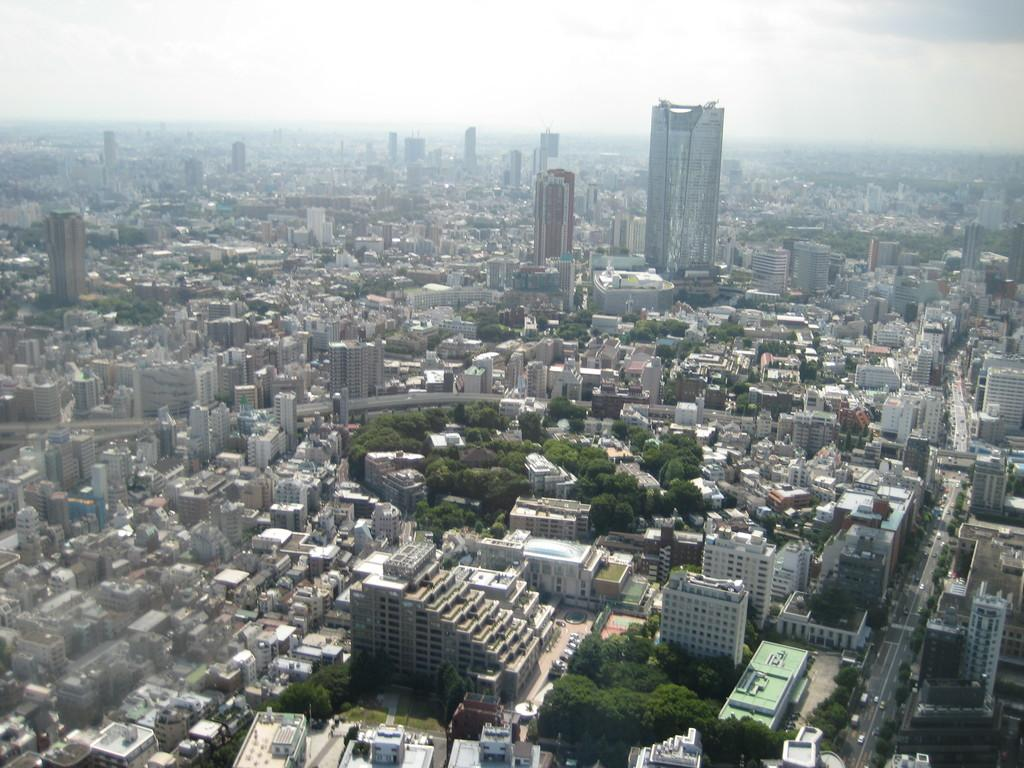What type of view is shown in the image? The image shows a top view of a city. What structures can be seen in the image? There are buildings in the image. What is visible at the top of the image? The sky is visible at the top of the image. How many patches can be seen on the toes of the buildings in the image? There are no patches or toes present on the buildings in the image, as they are not living beings. 